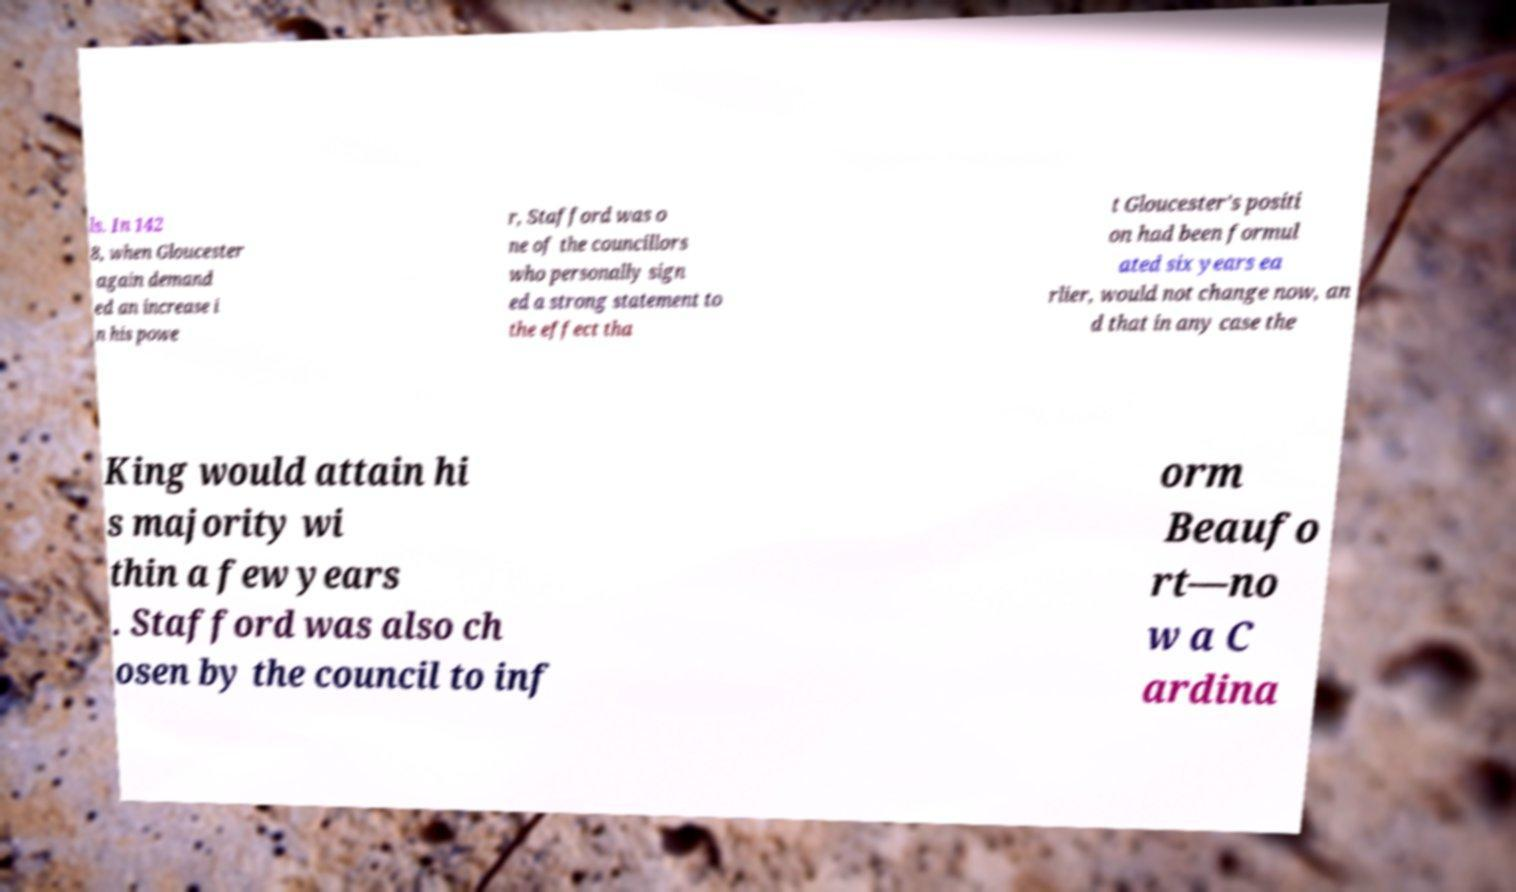There's text embedded in this image that I need extracted. Can you transcribe it verbatim? ls. In 142 8, when Gloucester again demand ed an increase i n his powe r, Stafford was o ne of the councillors who personally sign ed a strong statement to the effect tha t Gloucester's positi on had been formul ated six years ea rlier, would not change now, an d that in any case the King would attain hi s majority wi thin a few years . Stafford was also ch osen by the council to inf orm Beaufo rt—no w a C ardina 